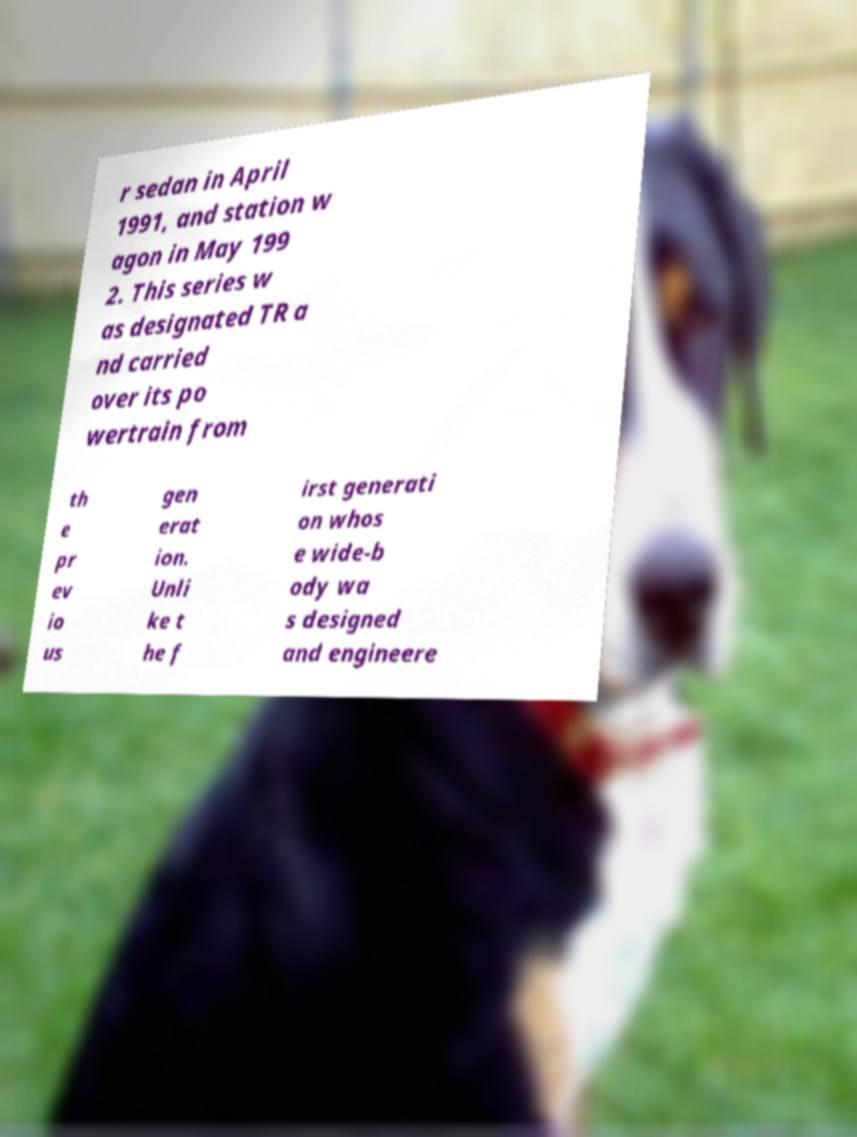For documentation purposes, I need the text within this image transcribed. Could you provide that? r sedan in April 1991, and station w agon in May 199 2. This series w as designated TR a nd carried over its po wertrain from th e pr ev io us gen erat ion. Unli ke t he f irst generati on whos e wide-b ody wa s designed and engineere 